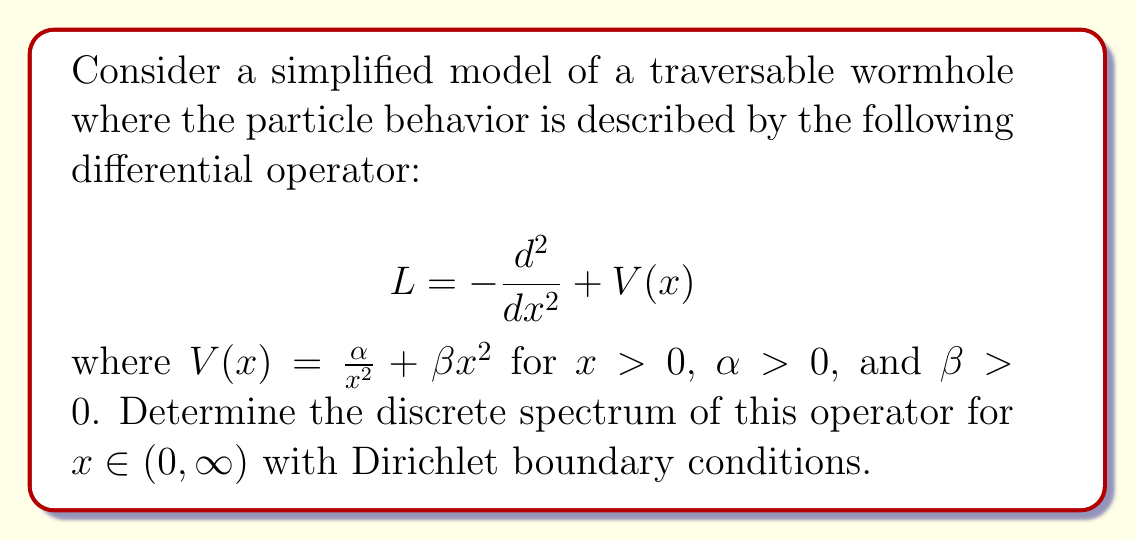Help me with this question. To find the discrete spectrum of the operator $L$, we need to solve the eigenvalue problem:

$$L\psi = E\psi$$

1) First, let's write out the full equation:

   $$-\frac{d^2\psi}{dx^2} + \left(\frac{\alpha}{x^2} + \beta x^2\right)\psi = E\psi$$

2) This equation resembles the radial part of the 3D harmonic oscillator with an additional centrifugal term. We can solve it using the asymptotic behavior and power series method.

3) For $x \to 0$, the dominant term is $\frac{\alpha}{x^2}$. The solution behaves as $x^{s}$ where $s(s-1) = \alpha$. We choose the positive root: $s = \frac{1}{2}(1 + \sqrt{1 + 4\alpha})$.

4) For $x \to \infty$, the dominant term is $\beta x^2$. The solution behaves as $e^{-\sqrt{\beta}x^2/2}$.

5) Based on these asymptotic behaviors, we can write the general form of the solution:

   $$\psi(x) = x^s e^{-\sqrt{\beta}x^2/2} f(x)$$

   where $f(x)$ is a polynomial.

6) Substituting this into the original equation and simplifying, we get:

   $$x\frac{d^2f}{dx^2} + (2s+1-2\sqrt{\beta}x^2)\frac{df}{dx} + (E-\sqrt{\beta}(2s+1))f = 0$$

7) This is a confluent hypergeometric equation. For the solution to be normalizable, $f$ must be a polynomial, which occurs when:

   $$E = \sqrt{\beta}(4n + 2s + 1)$$

   where $n = 0, 1, 2, ...$ is the principal quantum number.

8) Substituting $s = \frac{1}{2}(1 + \sqrt{1 + 4\alpha})$, we get the final expression for the discrete spectrum:

   $$E_n = \sqrt{\beta}\left(4n + 2 + \sqrt{1 + 4\alpha}\right)$$
Answer: $E_n = \sqrt{\beta}\left(4n + 2 + \sqrt{1 + 4\alpha}\right)$, $n = 0, 1, 2, ...$ 